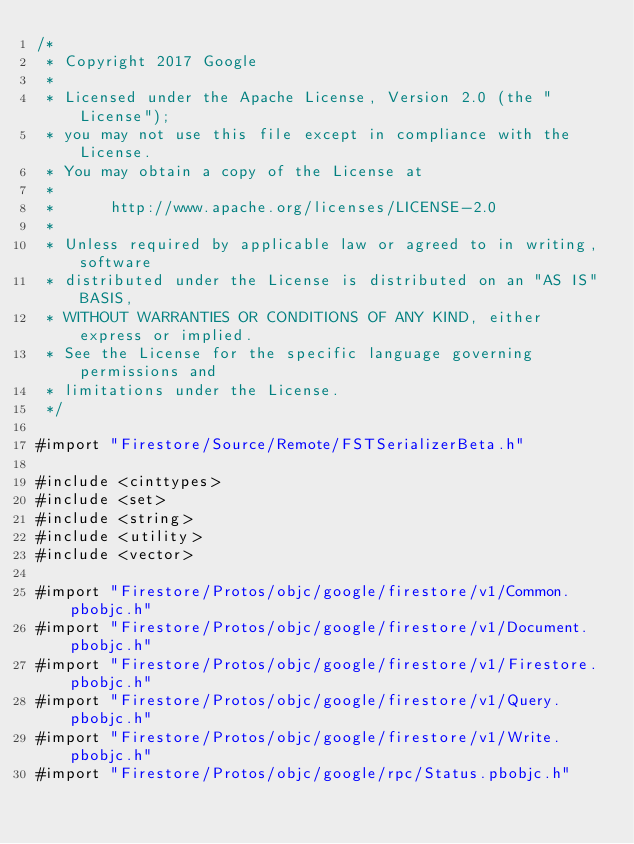Convert code to text. <code><loc_0><loc_0><loc_500><loc_500><_ObjectiveC_>/*
 * Copyright 2017 Google
 *
 * Licensed under the Apache License, Version 2.0 (the "License");
 * you may not use this file except in compliance with the License.
 * You may obtain a copy of the License at
 *
 *      http://www.apache.org/licenses/LICENSE-2.0
 *
 * Unless required by applicable law or agreed to in writing, software
 * distributed under the License is distributed on an "AS IS" BASIS,
 * WITHOUT WARRANTIES OR CONDITIONS OF ANY KIND, either express or implied.
 * See the License for the specific language governing permissions and
 * limitations under the License.
 */

#import "Firestore/Source/Remote/FSTSerializerBeta.h"

#include <cinttypes>
#include <set>
#include <string>
#include <utility>
#include <vector>

#import "Firestore/Protos/objc/google/firestore/v1/Common.pbobjc.h"
#import "Firestore/Protos/objc/google/firestore/v1/Document.pbobjc.h"
#import "Firestore/Protos/objc/google/firestore/v1/Firestore.pbobjc.h"
#import "Firestore/Protos/objc/google/firestore/v1/Query.pbobjc.h"
#import "Firestore/Protos/objc/google/firestore/v1/Write.pbobjc.h"
#import "Firestore/Protos/objc/google/rpc/Status.pbobjc.h"</code> 